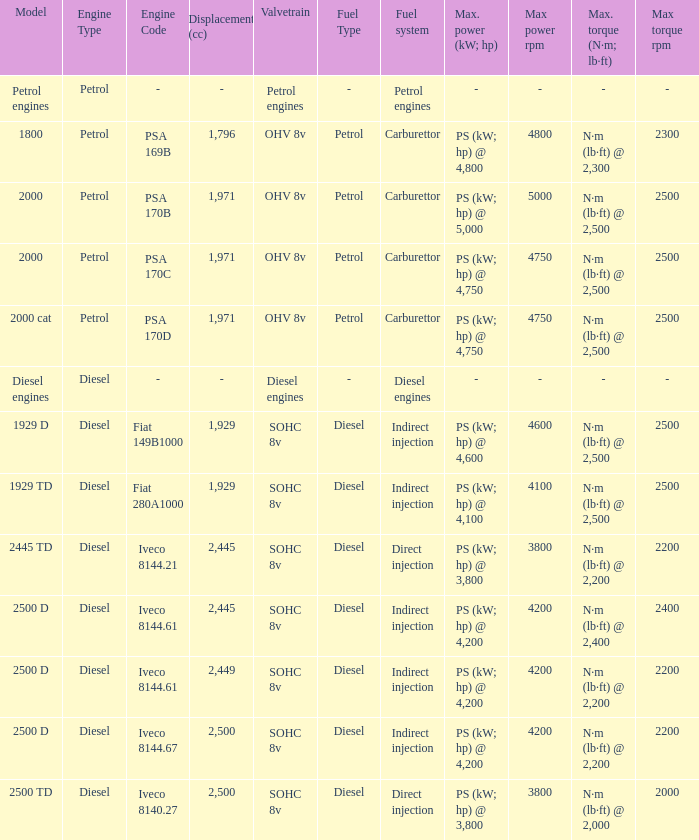In which valvetrain is the fuel system comprised of gasoline-powered engines? Petrol engines. 